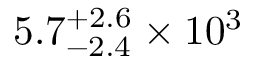<formula> <loc_0><loc_0><loc_500><loc_500>5 . 7 _ { - 2 . 4 } ^ { + 2 . 6 } \times 1 0 ^ { 3 }</formula> 